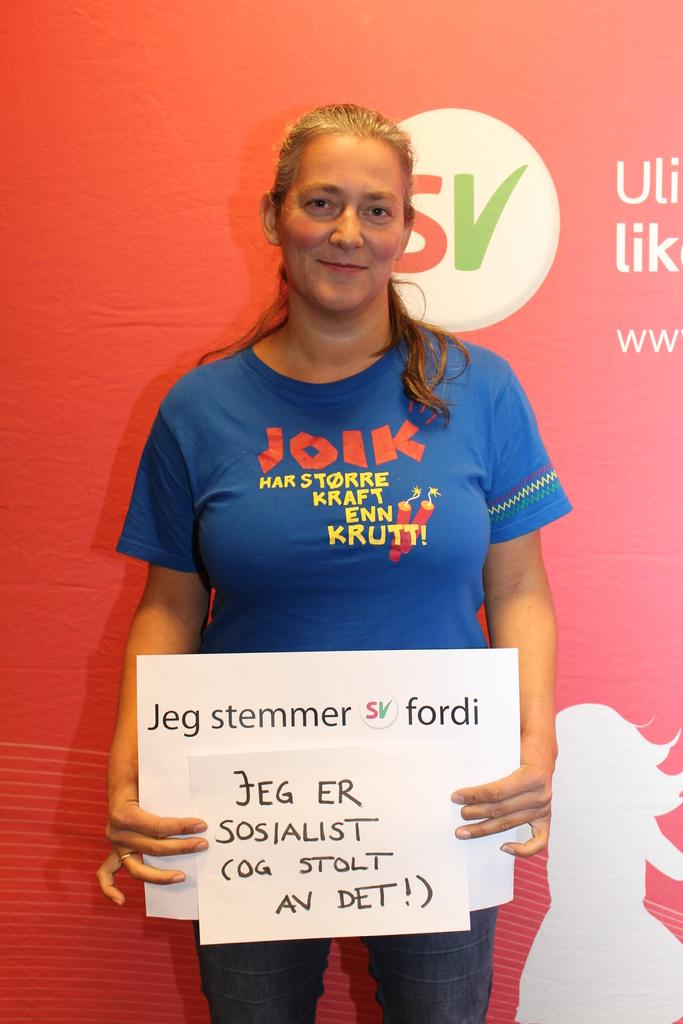Who is present in the image? There is a person in the image. What is the person wearing? The person is wearing a blue shirt. What object is the person holding? The person is holding a white board. What can be seen in the background of the image? There is a red banner in the background of the image. What type of suggestion can be seen on the white board in the image? There is no suggestion visible on the white board in the image. 